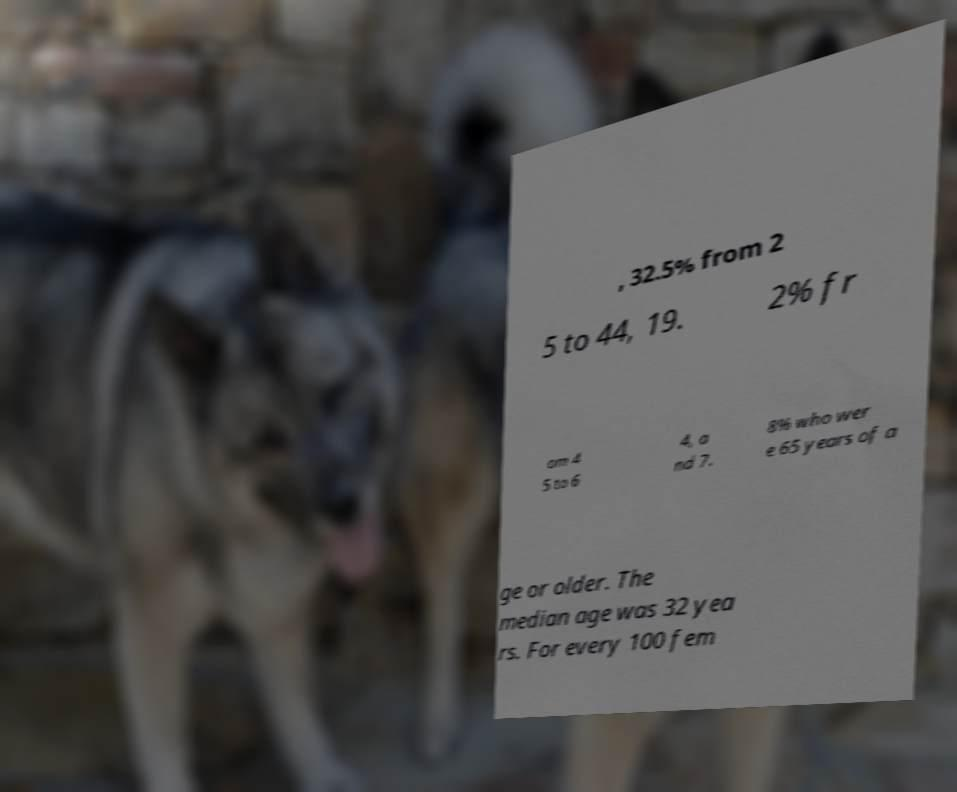Can you read and provide the text displayed in the image?This photo seems to have some interesting text. Can you extract and type it out for me? , 32.5% from 2 5 to 44, 19. 2% fr om 4 5 to 6 4, a nd 7. 8% who wer e 65 years of a ge or older. The median age was 32 yea rs. For every 100 fem 